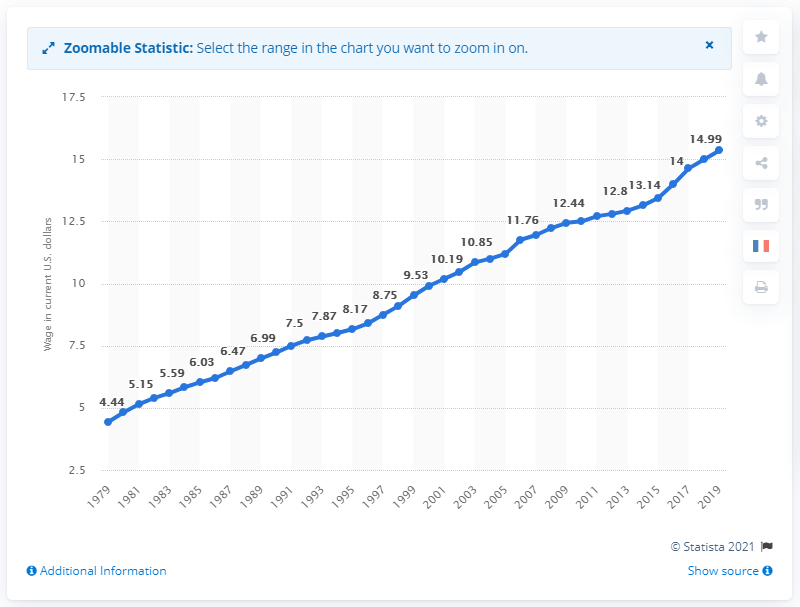Outline some significant characteristics in this image. The median hourly earnings of wage and salary workers in 2019 was 15.35. The median hourly earnings of wage and salary workers were $4.44 in 1979. 